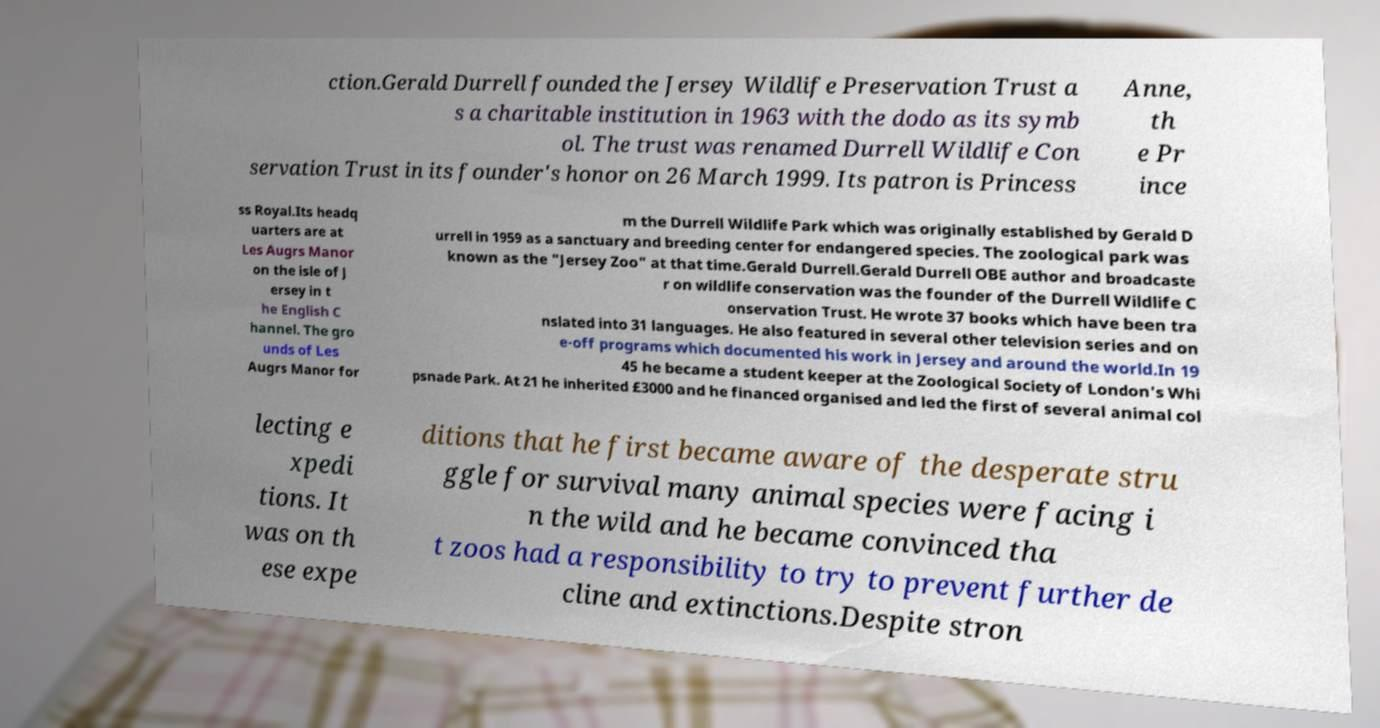Please identify and transcribe the text found in this image. ction.Gerald Durrell founded the Jersey Wildlife Preservation Trust a s a charitable institution in 1963 with the dodo as its symb ol. The trust was renamed Durrell Wildlife Con servation Trust in its founder's honor on 26 March 1999. Its patron is Princess Anne, th e Pr ince ss Royal.Its headq uarters are at Les Augrs Manor on the isle of J ersey in t he English C hannel. The gro unds of Les Augrs Manor for m the Durrell Wildlife Park which was originally established by Gerald D urrell in 1959 as a sanctuary and breeding center for endangered species. The zoological park was known as the "Jersey Zoo" at that time.Gerald Durrell.Gerald Durrell OBE author and broadcaste r on wildlife conservation was the founder of the Durrell Wildlife C onservation Trust. He wrote 37 books which have been tra nslated into 31 languages. He also featured in several other television series and on e-off programs which documented his work in Jersey and around the world.In 19 45 he became a student keeper at the Zoological Society of London's Whi psnade Park. At 21 he inherited £3000 and he financed organised and led the first of several animal col lecting e xpedi tions. It was on th ese expe ditions that he first became aware of the desperate stru ggle for survival many animal species were facing i n the wild and he became convinced tha t zoos had a responsibility to try to prevent further de cline and extinctions.Despite stron 